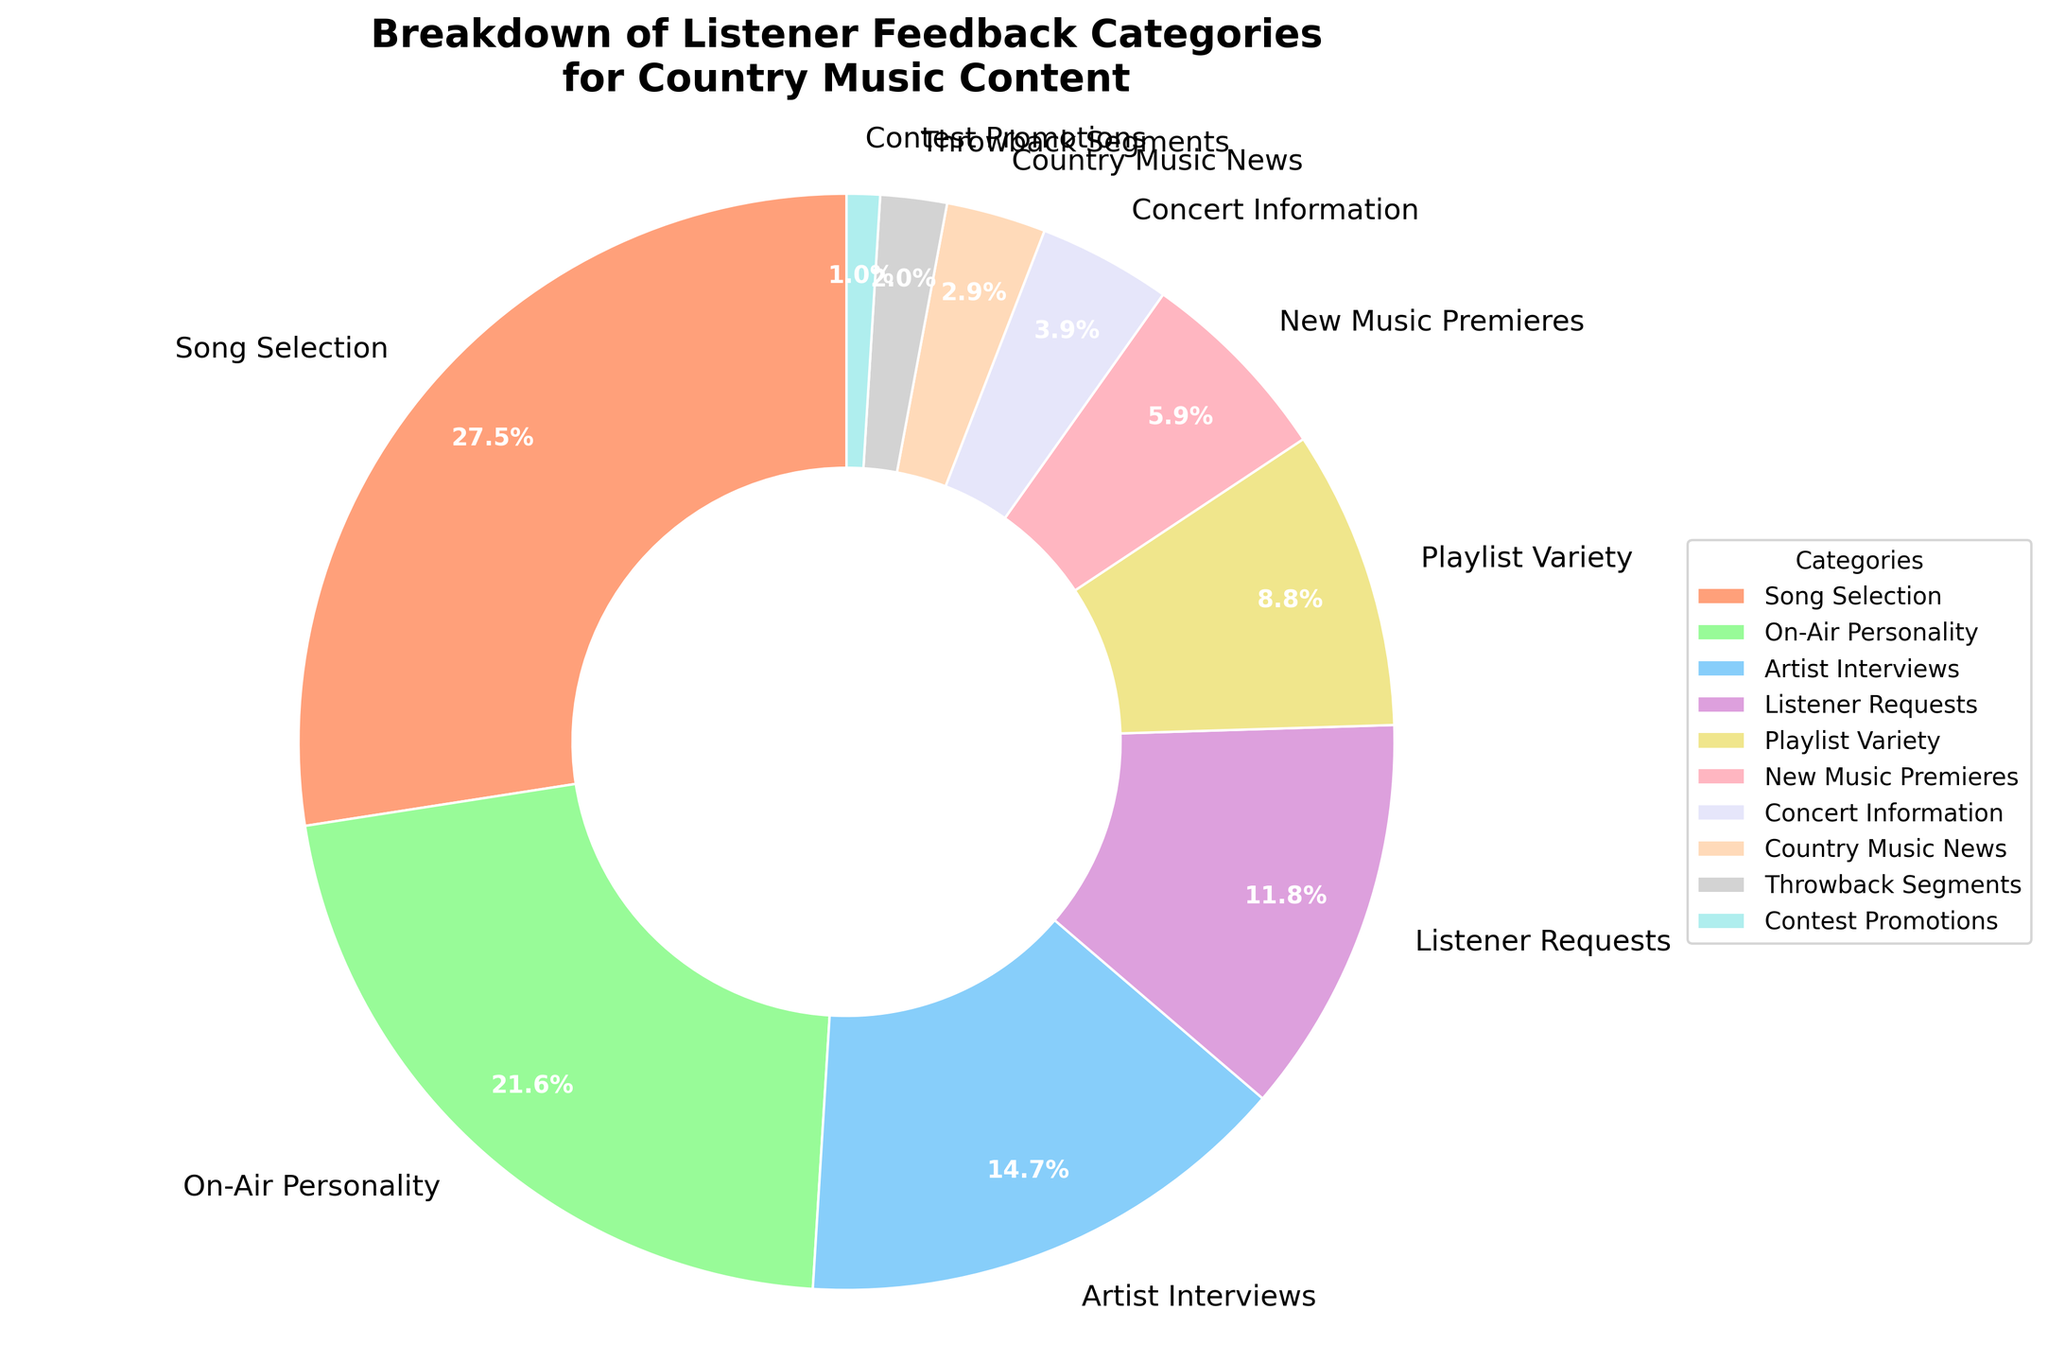What's the largest category in listener feedback for country music content? By looking at the pie chart, the largest wedge represents the "Song Selection" category, which has the highest percentage.
Answer: Song Selection Which category has the smallest representation in the listener feedback? The smallest wedge in the pie chart is for "Contest Promotions," which has the lowest percentage.
Answer: Contest Promotions What percentage of listener feedback is related to the "On-Air Personality" category? The "On-Air Personality" category is indicated in the pie chart with a value of 22%.
Answer: 22% What are the combined percentages of "Listener Requests" and "Playlist Variety"? According to the pie chart, "Listener Requests" is 12% and "Playlist Variety" is 9%. Their combined percentage is 12% + 9% = 21%.
Answer: 21% How much more feedback does "Song Selection" receive compared to "New Music Premieres"? "Song Selection" has 28% and "New Music Premieres" has 6%. The difference is 28% - 6% = 22%.
Answer: 22% Rank the top three categories based on percentages shown in the pie chart. By examining the pie chart, the categories from largest to smallest are: "Song Selection" (28%), "On-Air Personality" (22%), and "Artist Interviews" (15%).
Answer: Song Selection, On-Air Personality, Artist Interviews What's the combined percentage of the bottom three categories in the listener feedback? The three smallest categories are "Contest Promotions" (1%), "Throwback Segments" (2%), and "Country Music News" (3%). Their combined percentage is 1% + 2% + 3% = 6%.
Answer: 6% Which two categories have a combined percentage closest to that of "Song Selection"? "On-Air Personality" (22%) and "Artist Interviews" (15%) combine for 22% + 15% = 37%. However, the combination closest to "Song Selection" is "On-Air Personality" (22%) and "Listener Requests" (12%) which add up to 22% + 12% = 34%.
Answer: On-Air Personality and Listener Requests 